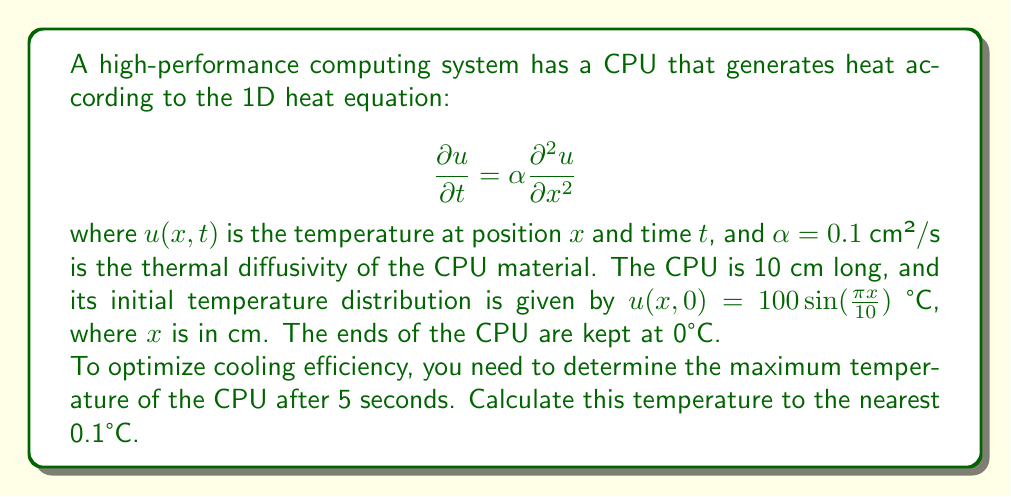Give your solution to this math problem. Let's approach this step-by-step:

1) The heat equation with the given boundary and initial conditions can be solved using separation of variables. The solution has the form:

   $$u(x,t) = \sum_{n=1}^{\infty} B_n \sin(\frac{n\pi x}{L}) e^{-\alpha(\frac{n\pi}{L})^2t}$$

   where $L$ is the length of the CPU (10 cm).

2) Given the initial condition, we can see that only the first term of the series (n=1) is non-zero:

   $$u(x,0) = B_1 \sin(\frac{\pi x}{10}) = 100 \sin(\frac{\pi x}{10})$$

   Therefore, $B_1 = 100$ and all other $B_n = 0$ for $n > 1$.

3) Our solution simplifies to:

   $$u(x,t) = 100 \sin(\frac{\pi x}{10}) e^{-\alpha(\frac{\pi}{10})^2t}$$

4) To find the maximum temperature at t = 5s, we need to maximize this function with respect to x:

   $$u(x,5) = 100 \sin(\frac{\pi x}{10}) e^{-0.1(\frac{\pi}{10})^2 \cdot 5}$$

5) The sine function reaches its maximum of 1 when its argument is $\frac{\pi}{2}$, which occurs at $x = 5$ cm (the middle of the CPU).

6) Therefore, the maximum temperature is:

   $$u_{max}(5) = 100 \cdot e^{-0.1(\frac{\pi}{10})^2 \cdot 5}$$

7) Calculating this:

   $$u_{max}(5) = 100 \cdot e^{-0.1(\frac{\pi^2}{100}) \cdot 5} \approx 95.1°C$$

8) Rounding to the nearest 0.1°C gives 95.1°C.
Answer: 95.1°C 